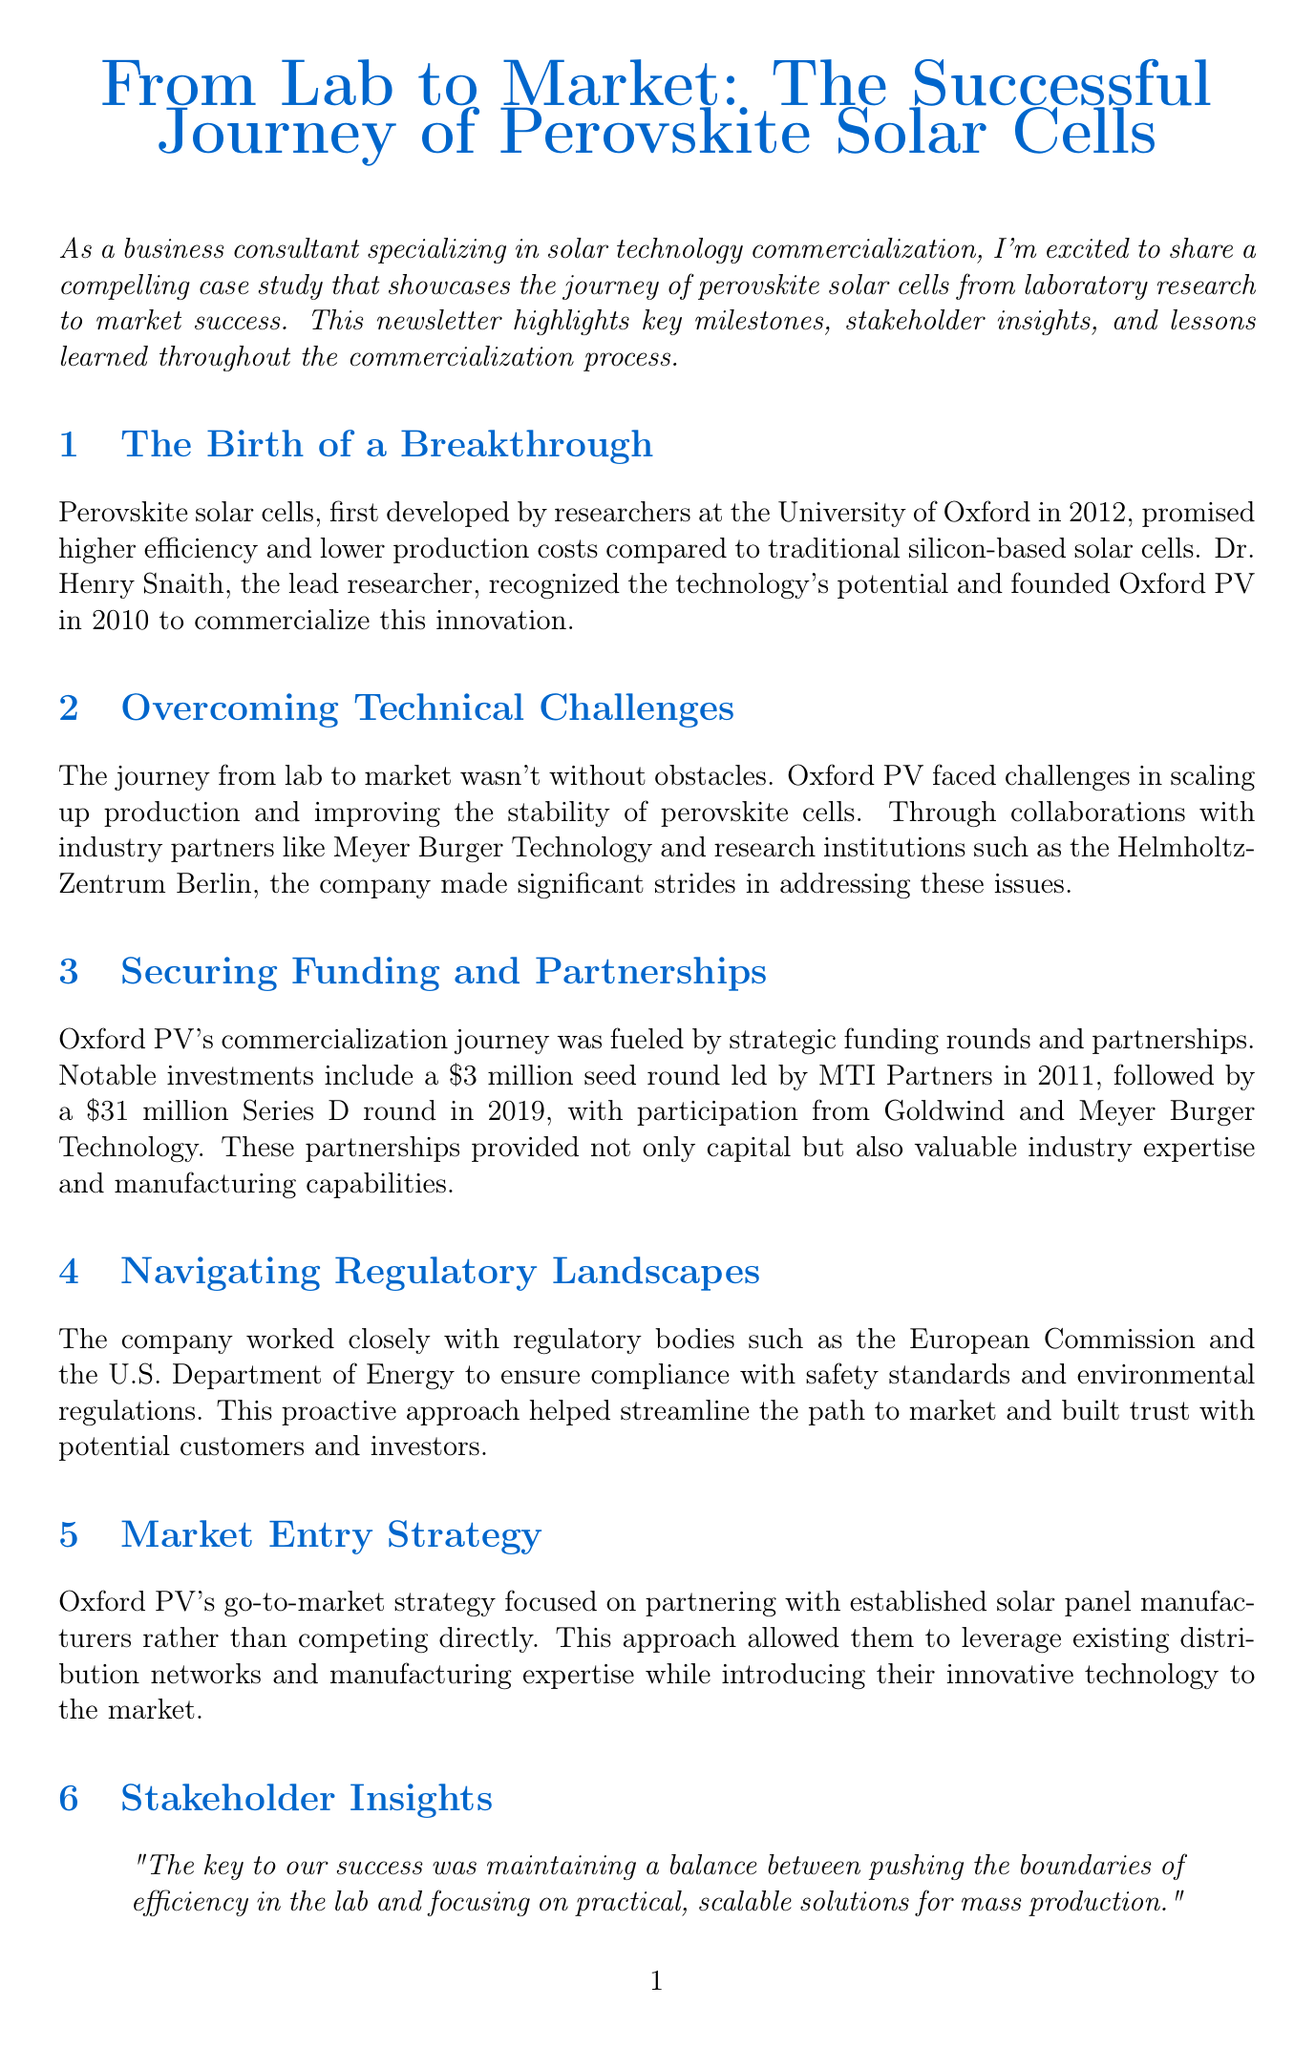What year were perovskite solar cells first developed? The document states that perovskite solar cells were first developed by researchers in 2012.
Answer: 2012 Who is the lead researcher associated with Oxford PV? The document indicates that Dr. Henry Snaith is the lead researcher who recognized the technology's potential.
Answer: Dr. Henry Snaith What was the amount of the seed round investment in 2011? The document mentions that the seed round investment in 2011 was $3 million.
Answer: $3 million What efficiency percentage was achieved by the tandem solar cells? The document reports that the tandem solar cells achieved a record-breaking efficiency of 29.52%.
Answer: 29.52% What strategic focus did Oxford PV have for their market entry strategy? The document explains that Oxford PV focused on partnering with established solar panel manufacturers for their market entry strategy.
Answer: Partnering with established solar panel manufacturers Which regulatory bodies did Oxford PV collaborate with? The document notes that Oxford PV worked closely with the European Commission and the U.S. Department of Energy.
Answer: European Commission and U.S. Department of Energy What role did partnerships play in Oxford PV's success according to Frank P. Averdung? The document indicates that Frank P. Averdung believes partnerships were crucial in bridging the gap between academic research and commercial viability.
Answer: Crucial in bridging the gap What significant challenge did Oxford PV face in scaling up production? The document mentions that they faced challenges in improving the stability of perovskite cells during the scaling up of production.
Answer: Improving stability of perovskite cells What is the main lesson highlighted in the conclusion of the newsletter? The conclusion emphasizes the importance of strategic partnerships, persistent innovation, and a clear commercialization strategy.
Answer: Strategic partnerships, persistent innovation, clear commercialization strategy 